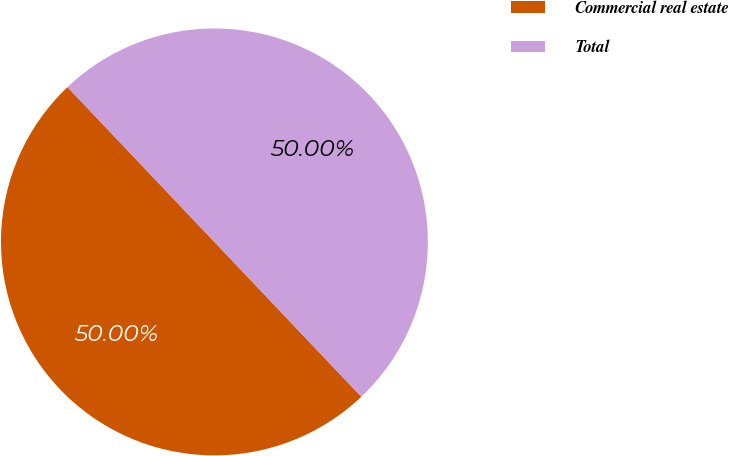<chart> <loc_0><loc_0><loc_500><loc_500><pie_chart><fcel>Commercial real estate<fcel>Total<nl><fcel>50.0%<fcel>50.0%<nl></chart> 